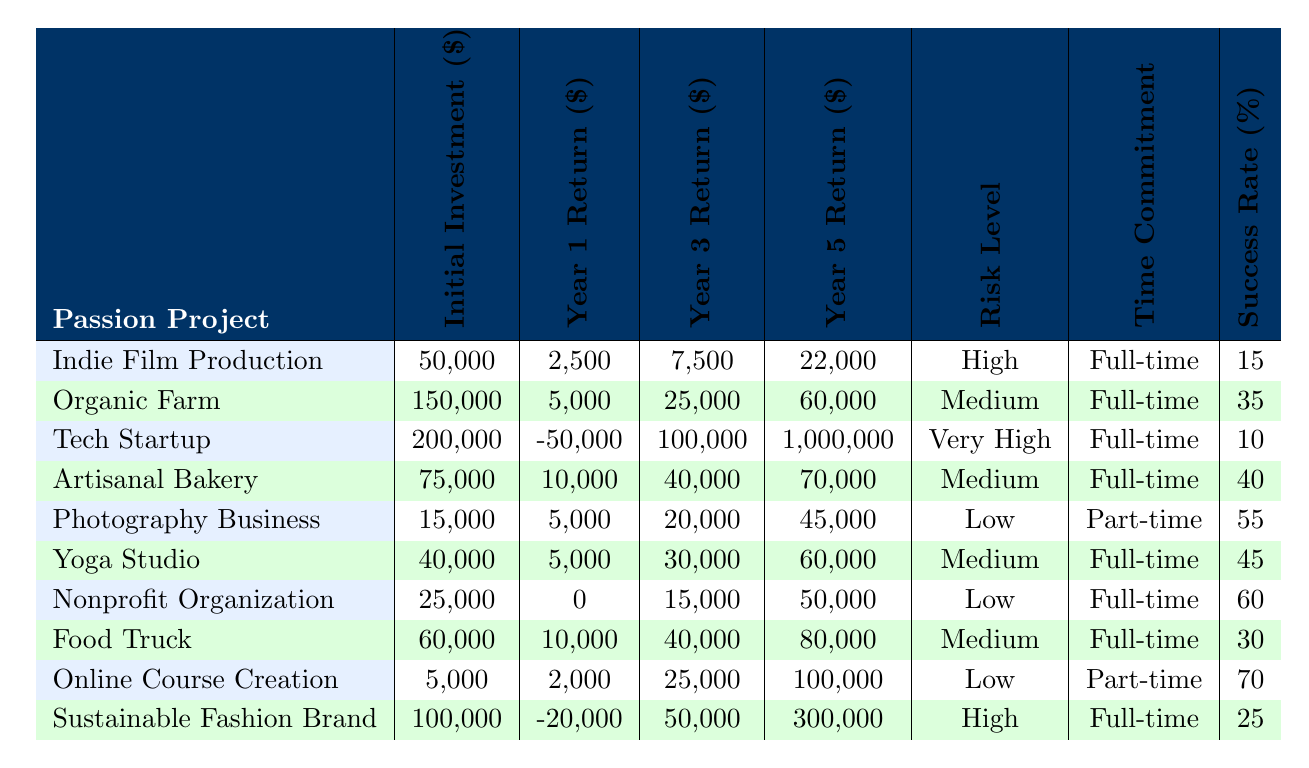What is the initial investment for the Yoga Studio? The table shows that the initial investment for the Yoga Studio is listed in the respective column, which is 40,000 dollars.
Answer: 40,000 Which project has the highest success rate? By comparing the success rates of all projects in the designated column, the Photography Business has the highest success rate listed as 55%.
Answer: Photography Business What are the total returns for the Technical Startup in Year 2 and Year 4? The Year 2 return is -30,000 and the Year 4 return is 500,000. Adding these two amounts (-30,000 + 500,000) gives us a total return of 470,000 dollars.
Answer: 470,000 Is the Organic Farm a low-risk project? The table categorizes the Organic Farm's risk level as Medium, which indicates that it is not considered low-risk.
Answer: No What is the difference between the initial investments of the Artisanal Bakery and the Photography Business? The initial investment for the Artisanal Bakery is 75,000 dollars and for the Photography Business it is 15,000 dollars. The difference is (75,000 - 15,000), which equals 60,000 dollars.
Answer: 60,000 Over the five years, which project generates the maximum return? By evaluating the Year 5 return for each project, the Tech Startup has a return of 1,000,000 dollars, which is the highest among all projects listed.
Answer: Tech Startup What is the average Year 1 return for projects with a Medium risk level? The projects with Medium risk levels are Organic Farm, Artisanal Bakery, Yoga Studio, Food Truck, and Sustainable Fashion Brand. Their Year 1 returns are 5,000, 10,000, 5,000, 10,000, and -20,000, respectively. The total is (5,000 + 10,000 + 5,000 + 10,000 + -20,000) = 10,000. Dividing by 5 gives an average of 2,000 dollars.
Answer: 2,000 Which project requires a part-time commitment? The only project classified under part-time commitment is the Photography Business, as observed in the Time Commitment column.
Answer: Photography Business How many projects have a significant potential career impact? The projects identified with a significant potential career impact are Indie Film Production, Yoga Studio, Online Course Creation, and Nonprofit Organization. This totals 4 projects.
Answer: 4 What is the Year 3 return for the Nonprofit Organization? The Year 3 return for the Nonprofit Organization is explicitly mentioned in the respective column as 15,000 dollars.
Answer: 15,000 Which project has both the highest initial investment and the highest Year 5 return? The Tech Startup has the highest initial investment at 200,000 dollars and also the highest Year 5 return listed at 1,000,000 dollars, making it unique in this respect.
Answer: Tech Startup 